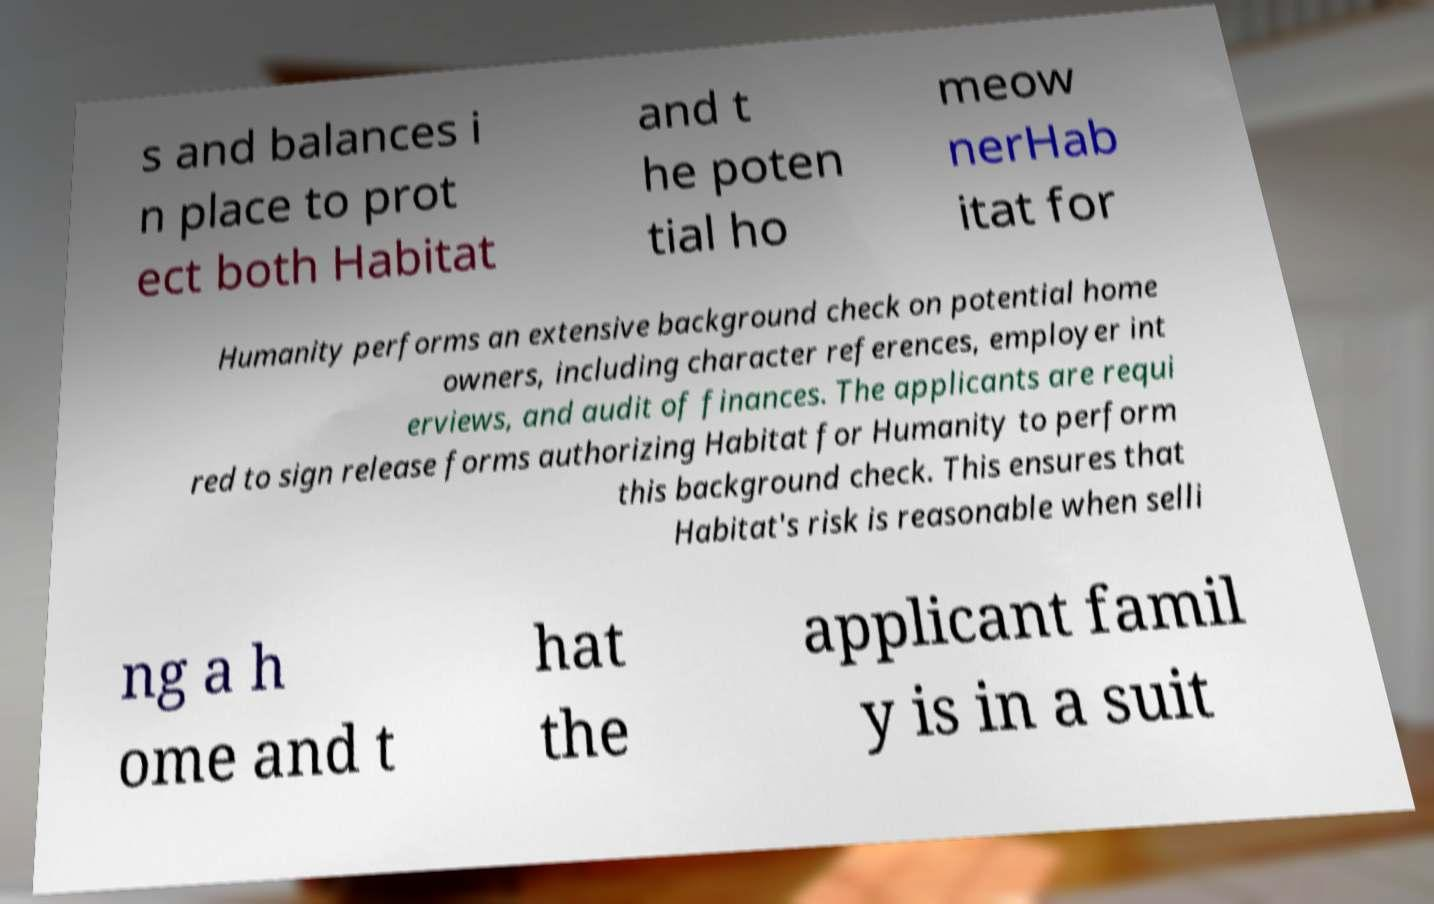Could you extract and type out the text from this image? s and balances i n place to prot ect both Habitat and t he poten tial ho meow nerHab itat for Humanity performs an extensive background check on potential home owners, including character references, employer int erviews, and audit of finances. The applicants are requi red to sign release forms authorizing Habitat for Humanity to perform this background check. This ensures that Habitat's risk is reasonable when selli ng a h ome and t hat the applicant famil y is in a suit 